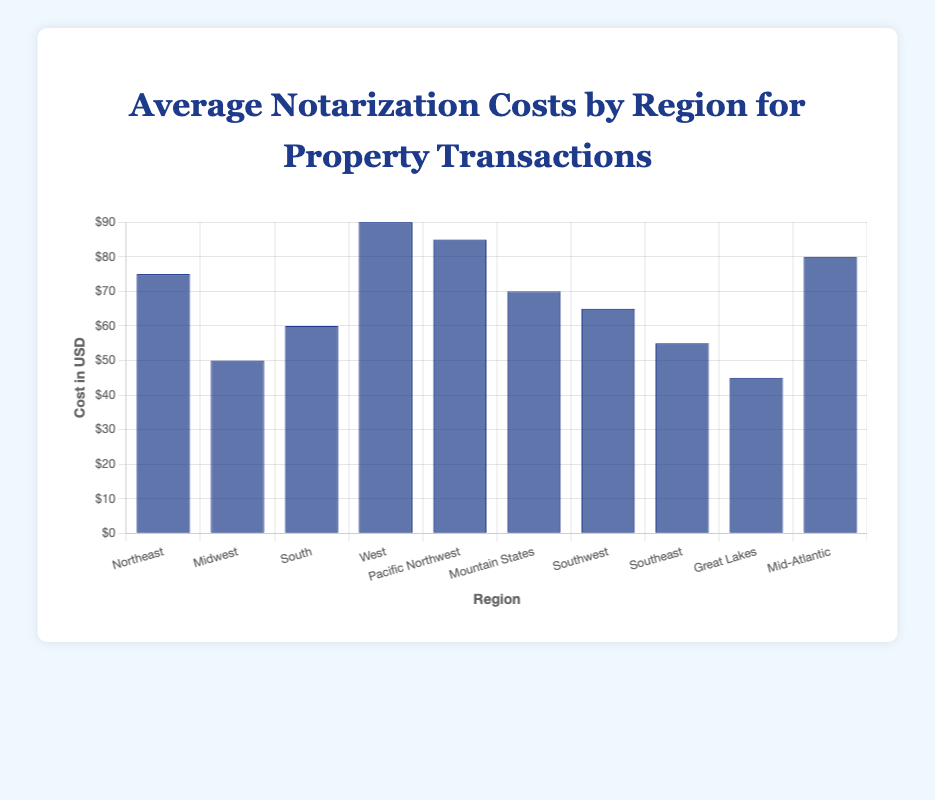What is the average notarization cost in the Northeast? Look at the bar representing the Northeast region. Its height indicates the average notarization cost.
Answer: $75 Which region has the highest average notarization cost? Compare the heights of all the bars. The tallest bar represents the highest average cost.
Answer: West What is the difference in average notarization costs between the West and the Great Lakes regions? Find the heights of the bars for the West and Great Lakes regions and subtract the Great Lakes value from the West. $90 - $45 = $45
Answer: $45 Which region has a higher average notarization cost, the Southwest or the Southeast? Compare the bar heights for the Southwest and Southeast regions. The taller bar represents the higher cost.
Answer: Southwest What is the combined average notarization cost for the Mountain States and the South? Look at the bars for the Mountain States and South regions, then add their values together. $70 + $60 = $130
Answer: $130 What is the average notarization cost across all regions? Sum the values of all the regions and then divide by the number of regions. (75 + 50 + 60 + 90 + 85 + 70 + 65 + 55 + 45 + 80) / 10 = $67.5
Answer: $67.5 Is the average notarization cost in the Mid-Atlantic region greater than $70? Check the bar for the Mid-Atlantic region and see if its height indicates a value greater than $70.
Answer: Yes What is the median value of average notarization costs? List all values (75, 50, 60, 90, 85, 70, 65, 55, 45, 80), arrange them in ascending order (45, 50, 55, 60, 65, 70, 75, 80, 85, 90), and find the middle value. Since there are 10 values, the median is the average of the 5th and 6th values: (65 + 70) / 2 = 67.5
Answer: 67.5 How much greater is the average notarization cost in the Northeast compared to the Southeast? Subtract the Southeast value from the Northeast value. $75 - $55 = $20
Answer: $20 